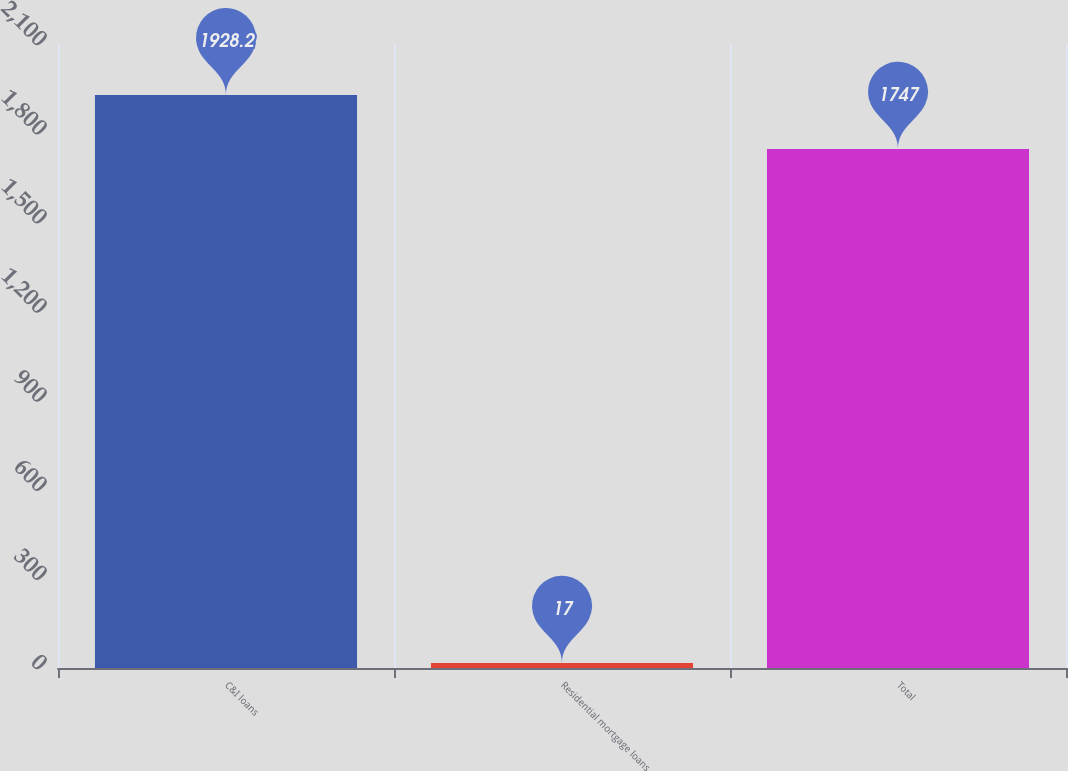Convert chart. <chart><loc_0><loc_0><loc_500><loc_500><bar_chart><fcel>C&I loans<fcel>Residential mortgage loans<fcel>Total<nl><fcel>1928.2<fcel>17<fcel>1747<nl></chart> 